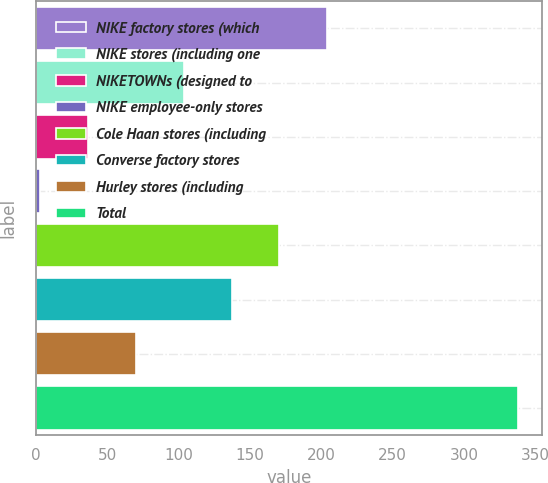<chart> <loc_0><loc_0><loc_500><loc_500><bar_chart><fcel>NIKE factory stores (which<fcel>NIKE stores (including one<fcel>NIKETOWNs (designed to<fcel>NIKE employee-only stores<fcel>Cole Haan stores (including<fcel>Converse factory stores<fcel>Hurley stores (including<fcel>Total<nl><fcel>204<fcel>103.5<fcel>36.5<fcel>3<fcel>170.5<fcel>137<fcel>70<fcel>338<nl></chart> 